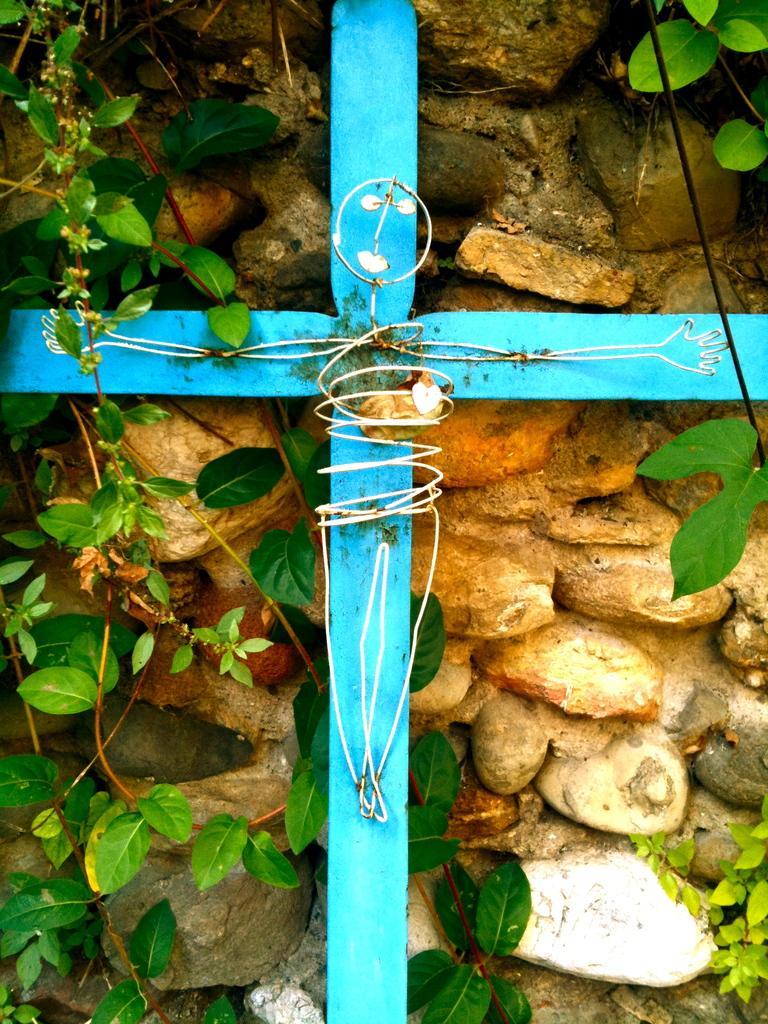In one or two sentences, can you explain what this image depicts? In this image I see the leaves and I see number of stones and I see the blue color sticks. 